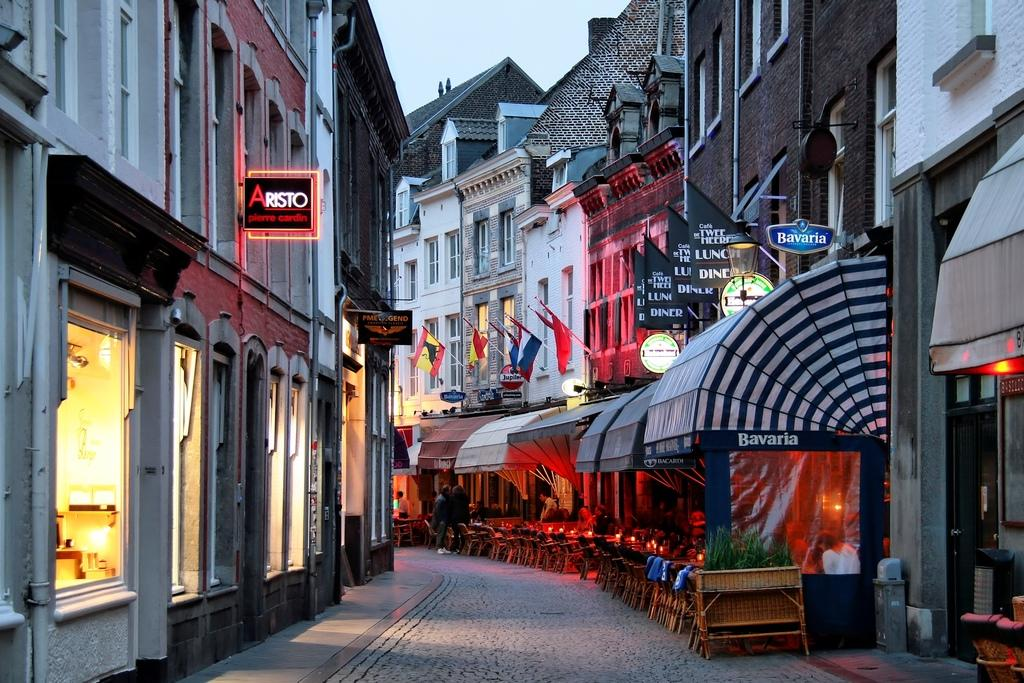What type of structures can be seen on the left side of the image? There are buildings with lights on the left side of the image. What is located in the middle of the image? There are dining stores in the middle of the image. What type of structures can be seen on the right side of the image? There are buildings on the right side of the image. What is visible at the top of the image? The sky is visible at the top of the image. Can you see a line of straws in the image? There is no line of straws present in the image. Is there a book visible in the image? There is no book visible in the image. 